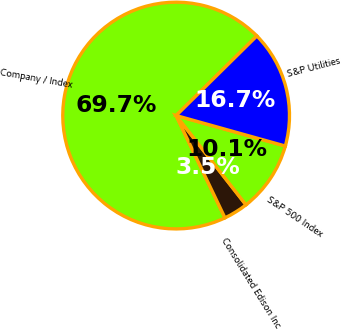Convert chart. <chart><loc_0><loc_0><loc_500><loc_500><pie_chart><fcel>Company / Index<fcel>Consolidated Edison Inc<fcel>S&P 500 Index<fcel>S&P Utilities<nl><fcel>69.7%<fcel>3.48%<fcel>10.1%<fcel>16.72%<nl></chart> 